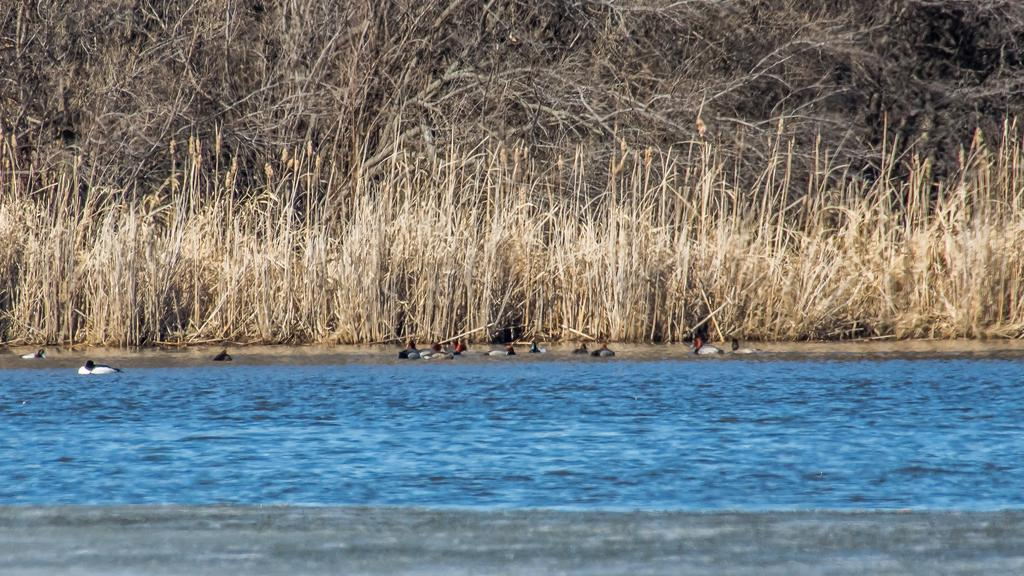What type of vegetation can be seen in the image? There are trees in the image. What are the birds doing in the image? The birds are swimming in the water in the image. What body of water is present in the image? There is a lake in the image. What type of prison can be seen in the image? There is no prison present in the image; it features trees, birds swimming in water, and a lake. What time of day is it in the image, given the presence of a lamp? There is no lamp present in the image, so it is not possible to determine the time of day. 